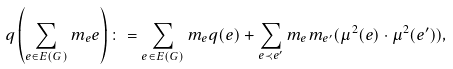Convert formula to latex. <formula><loc_0><loc_0><loc_500><loc_500>q \left ( \sum _ { e \in E ( G ) } m _ { e } e \right ) \colon = \sum _ { e \in E ( G ) } m _ { e } q ( e ) + \sum _ { e \prec e ^ { \prime } } m _ { e } m _ { e ^ { \prime } } ( \mu ^ { 2 } ( e ) \cdot \mu ^ { 2 } ( e ^ { \prime } ) ) ,</formula> 